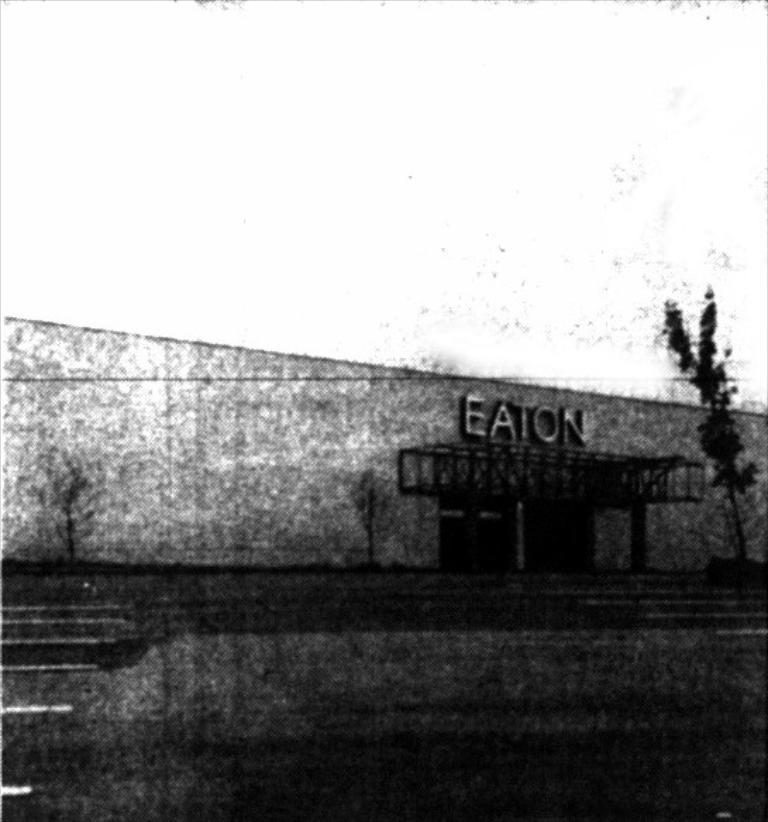<image>
Offer a succinct explanation of the picture presented. large letters spelling eaton on a wall in this grainy black & white image 